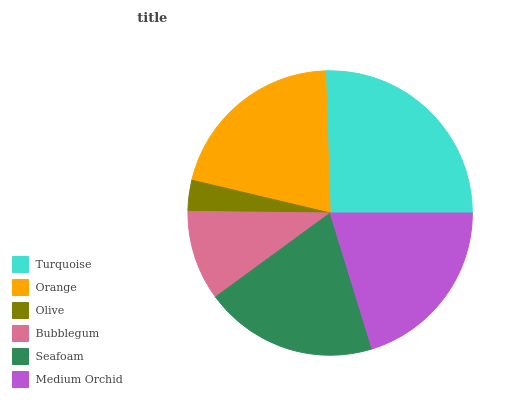Is Olive the minimum?
Answer yes or no. Yes. Is Turquoise the maximum?
Answer yes or no. Yes. Is Orange the minimum?
Answer yes or no. No. Is Orange the maximum?
Answer yes or no. No. Is Turquoise greater than Orange?
Answer yes or no. Yes. Is Orange less than Turquoise?
Answer yes or no. Yes. Is Orange greater than Turquoise?
Answer yes or no. No. Is Turquoise less than Orange?
Answer yes or no. No. Is Medium Orchid the high median?
Answer yes or no. Yes. Is Seafoam the low median?
Answer yes or no. Yes. Is Seafoam the high median?
Answer yes or no. No. Is Orange the low median?
Answer yes or no. No. 